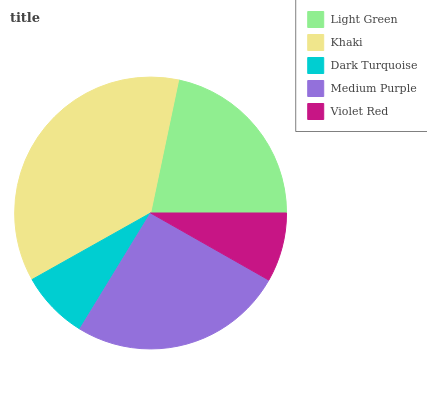Is Dark Turquoise the minimum?
Answer yes or no. Yes. Is Khaki the maximum?
Answer yes or no. Yes. Is Khaki the minimum?
Answer yes or no. No. Is Dark Turquoise the maximum?
Answer yes or no. No. Is Khaki greater than Dark Turquoise?
Answer yes or no. Yes. Is Dark Turquoise less than Khaki?
Answer yes or no. Yes. Is Dark Turquoise greater than Khaki?
Answer yes or no. No. Is Khaki less than Dark Turquoise?
Answer yes or no. No. Is Light Green the high median?
Answer yes or no. Yes. Is Light Green the low median?
Answer yes or no. Yes. Is Medium Purple the high median?
Answer yes or no. No. Is Medium Purple the low median?
Answer yes or no. No. 